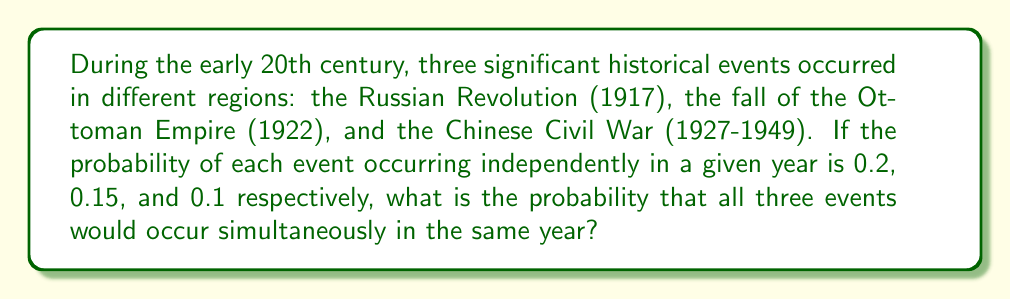What is the answer to this math problem? To solve this problem, we need to use the multiplication rule of probability for independent events. Since the events are occurring in different regions and are assumed to be independent, we can multiply their individual probabilities.

Let's define our events:
A: Russian Revolution occurs (P(A) = 0.2)
B: Fall of Ottoman Empire occurs (P(B) = 0.15)
C: Chinese Civil War occurs (P(C) = 0.1)

We want to find P(A ∩ B ∩ C), the probability of all three events occurring simultaneously.

For independent events:
$$P(A \cap B \cap C) = P(A) \times P(B) \times P(C)$$

Substituting the given probabilities:

$$P(A \cap B \cap C) = 0.2 \times 0.15 \times 0.1$$

Calculating:
$$P(A \cap B \cap C) = 0.003$$

Therefore, the probability of all three events occurring simultaneously in the same year is 0.003 or 0.3%.
Answer: 0.003 